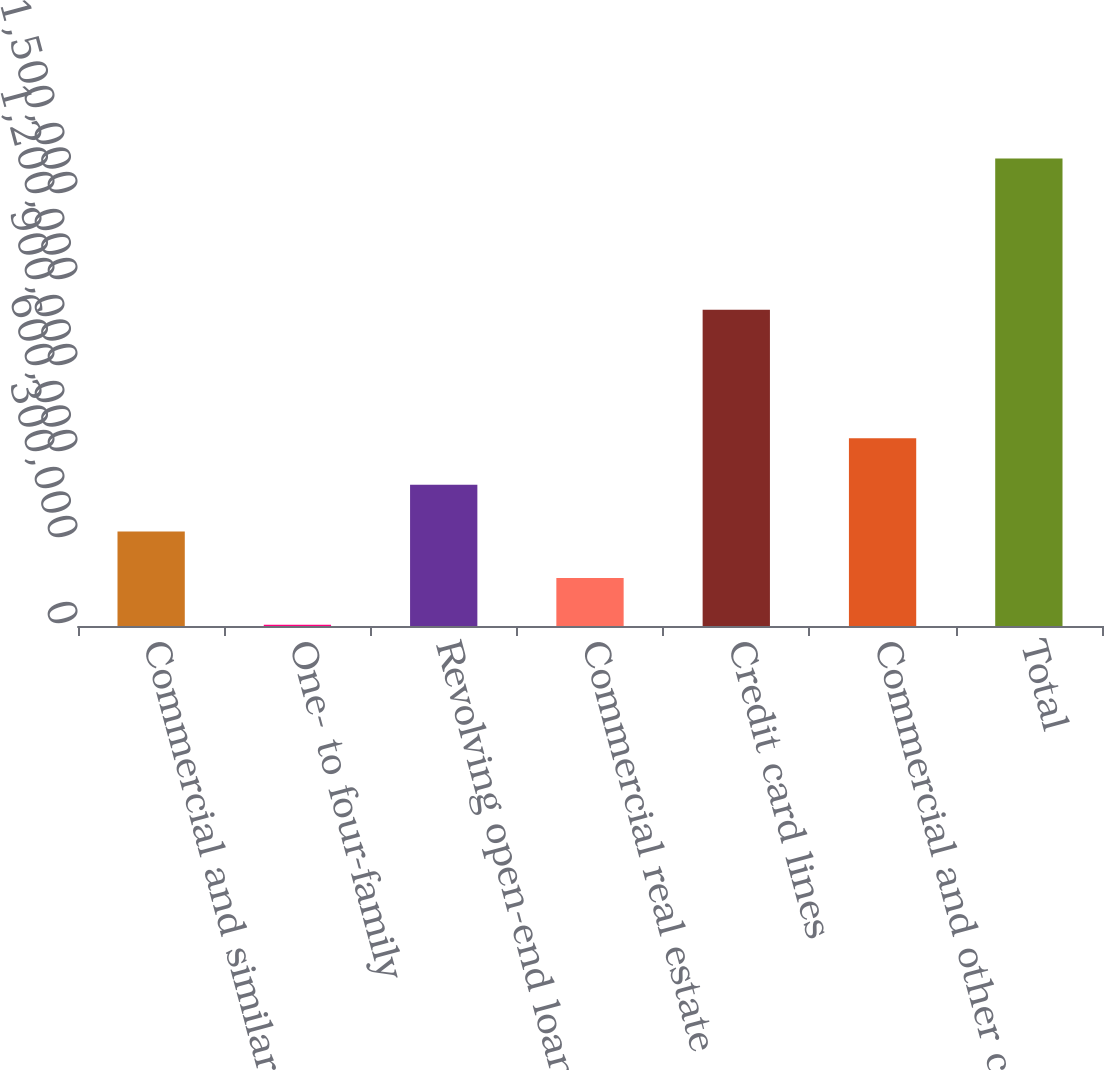Convert chart to OTSL. <chart><loc_0><loc_0><loc_500><loc_500><bar_chart><fcel>Commercial and similar letters<fcel>One- to four-family<fcel>Revolving open-end loans<fcel>Commercial real estate<fcel>Credit card lines<fcel>Commercial and other consumer<fcel>Total<nl><fcel>329859<fcel>4587<fcel>492496<fcel>167223<fcel>1.10354e+06<fcel>655132<fcel>1.63095e+06<nl></chart> 